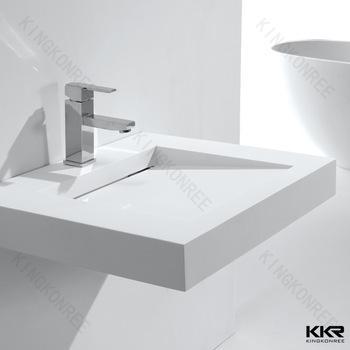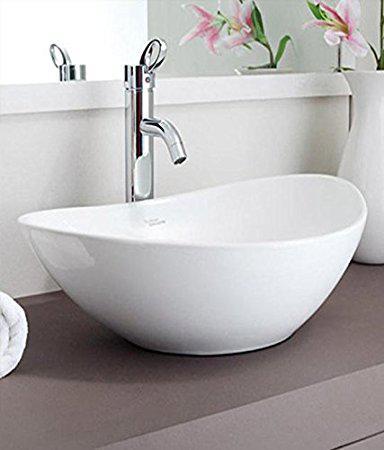The first image is the image on the left, the second image is the image on the right. Analyze the images presented: Is the assertion "The right image shows an oblong bowl-shaped sink." valid? Answer yes or no. Yes. 